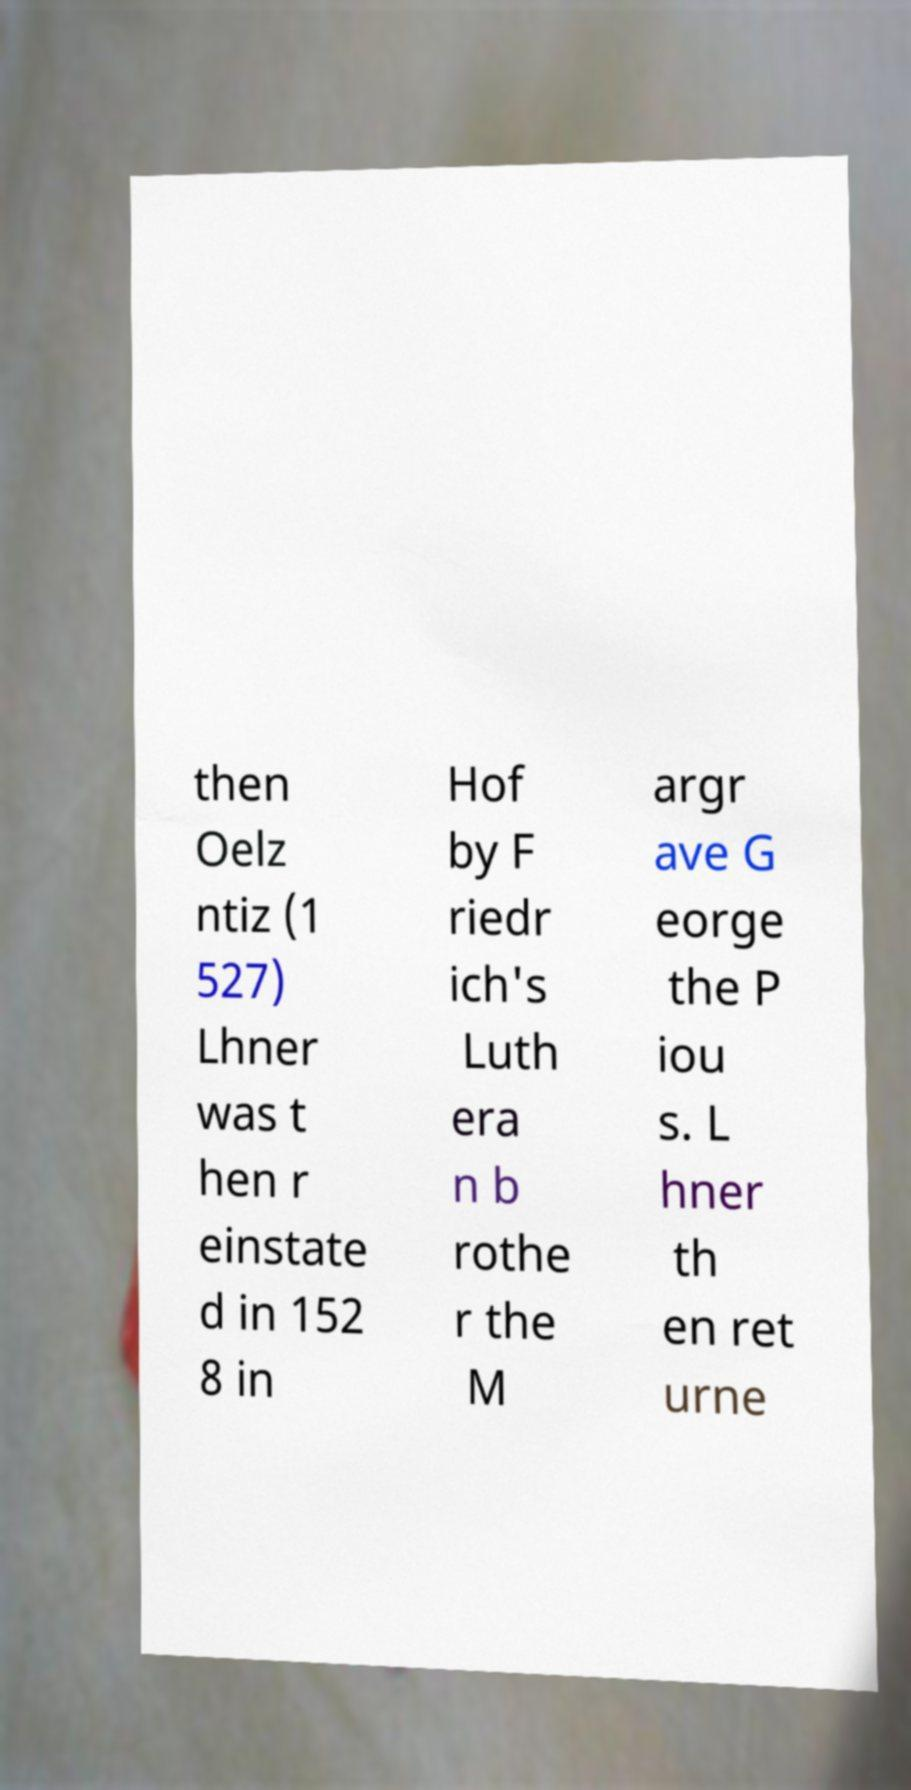I need the written content from this picture converted into text. Can you do that? then Oelz ntiz (1 527) Lhner was t hen r einstate d in 152 8 in Hof by F riedr ich's Luth era n b rothe r the M argr ave G eorge the P iou s. L hner th en ret urne 